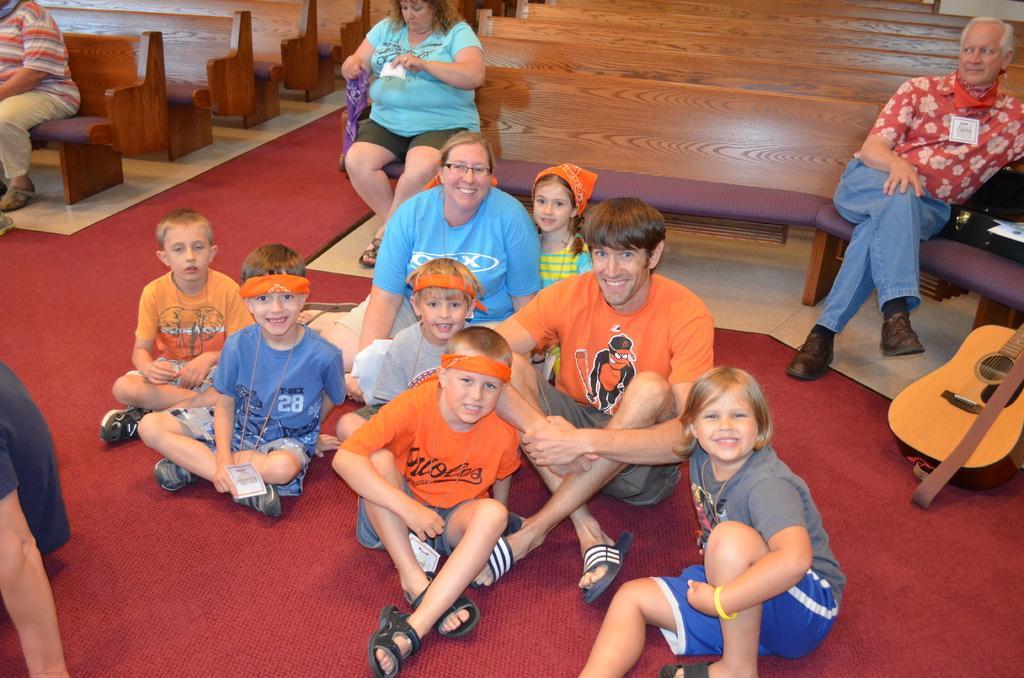Describe this image in one or two sentences. In this image there are group of persons sitting in a room at the foreground of the image there are persons sitting on the floor and at the background of the image there are persons sitting on the bench and at the right side of the image there is a guitar. 